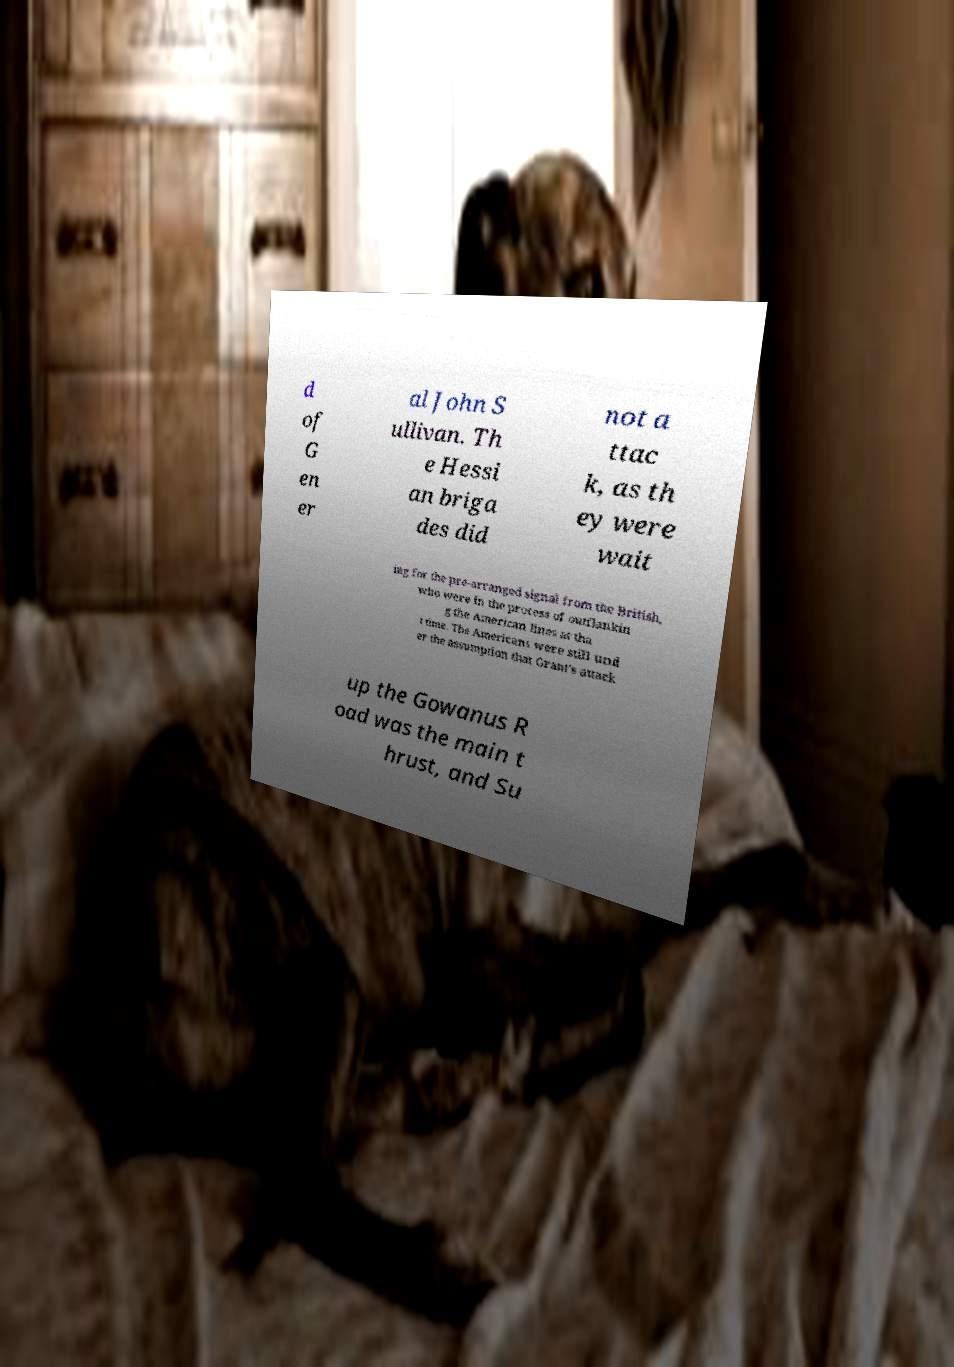Can you read and provide the text displayed in the image?This photo seems to have some interesting text. Can you extract and type it out for me? d of G en er al John S ullivan. Th e Hessi an briga des did not a ttac k, as th ey were wait ing for the pre-arranged signal from the British, who were in the process of outflankin g the American lines at tha t time. The Americans were still und er the assumption that Grant's attack up the Gowanus R oad was the main t hrust, and Su 